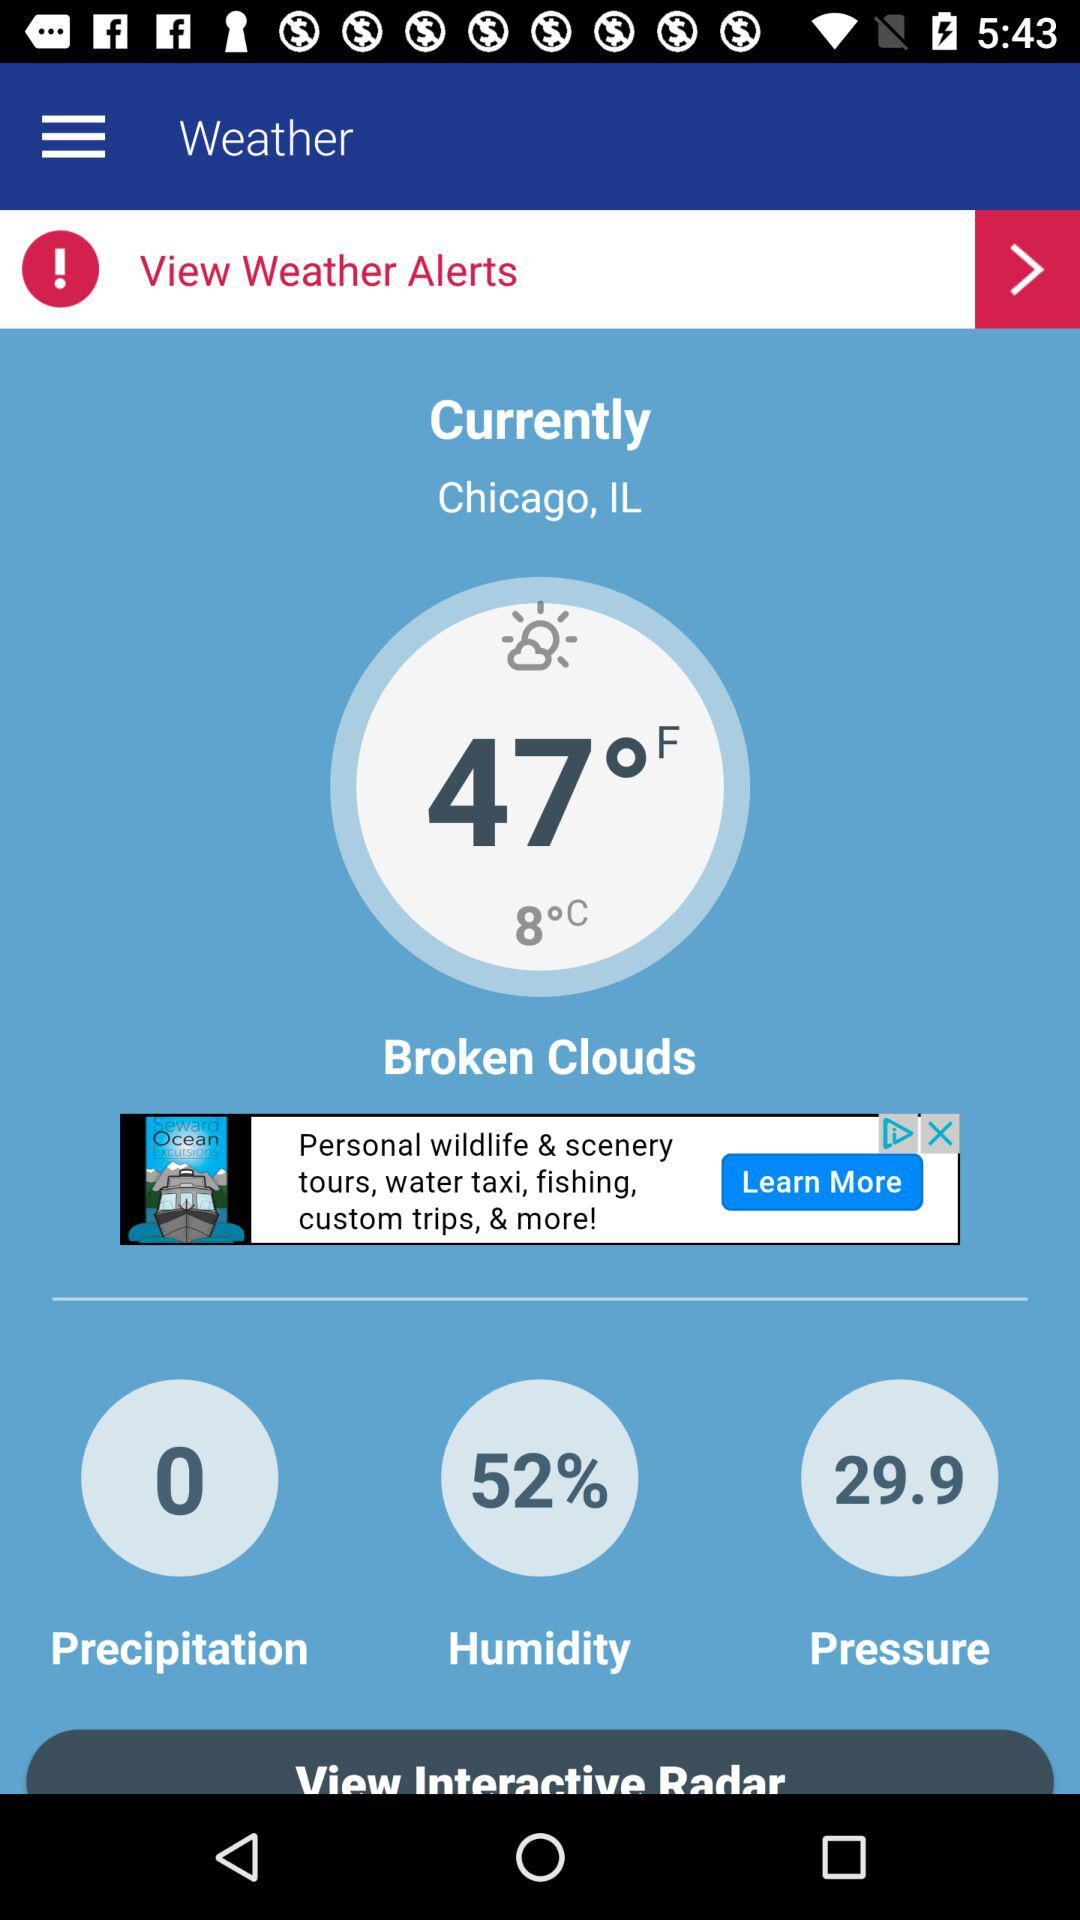What is the temperature?
When the provided information is insufficient, respond with <no answer>. <no answer> 